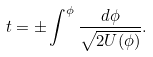<formula> <loc_0><loc_0><loc_500><loc_500>t = \pm \int ^ { \phi } \frac { d \phi } { \sqrt { 2 U ( \phi ) } } .</formula> 